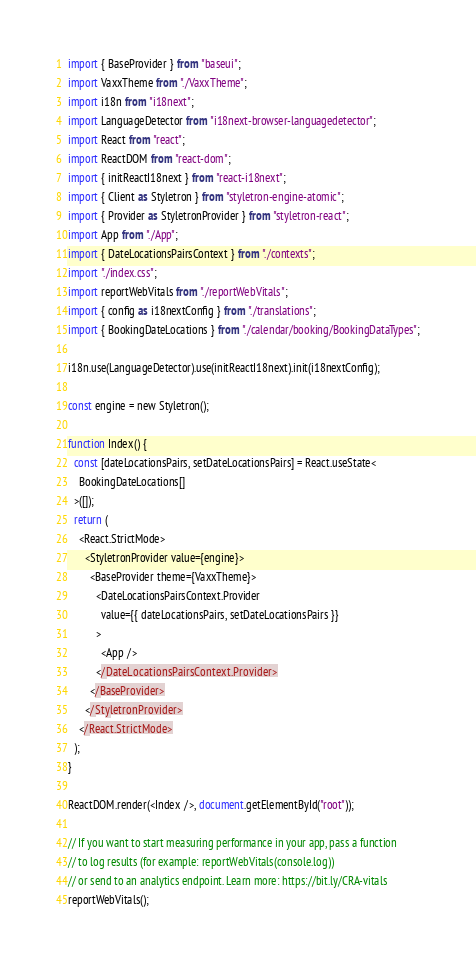<code> <loc_0><loc_0><loc_500><loc_500><_TypeScript_>import { BaseProvider } from "baseui";
import VaxxTheme from "./VaxxTheme";
import i18n from "i18next";
import LanguageDetector from "i18next-browser-languagedetector";
import React from "react";
import ReactDOM from "react-dom";
import { initReactI18next } from "react-i18next";
import { Client as Styletron } from "styletron-engine-atomic";
import { Provider as StyletronProvider } from "styletron-react";
import App from "./App";
import { DateLocationsPairsContext } from "./contexts";
import "./index.css";
import reportWebVitals from "./reportWebVitals";
import { config as i18nextConfig } from "./translations";
import { BookingDateLocations } from "./calendar/booking/BookingDataTypes";

i18n.use(LanguageDetector).use(initReactI18next).init(i18nextConfig);

const engine = new Styletron();

function Index() {
  const [dateLocationsPairs, setDateLocationsPairs] = React.useState<
    BookingDateLocations[]
  >([]);
  return (
    <React.StrictMode>
      <StyletronProvider value={engine}>
        <BaseProvider theme={VaxxTheme}>
          <DateLocationsPairsContext.Provider
            value={{ dateLocationsPairs, setDateLocationsPairs }}
          >
            <App />
          </DateLocationsPairsContext.Provider>
        </BaseProvider>
      </StyletronProvider>
    </React.StrictMode>
  );
}

ReactDOM.render(<Index />, document.getElementById("root"));

// If you want to start measuring performance in your app, pass a function
// to log results (for example: reportWebVitals(console.log))
// or send to an analytics endpoint. Learn more: https://bit.ly/CRA-vitals
reportWebVitals();
</code> 